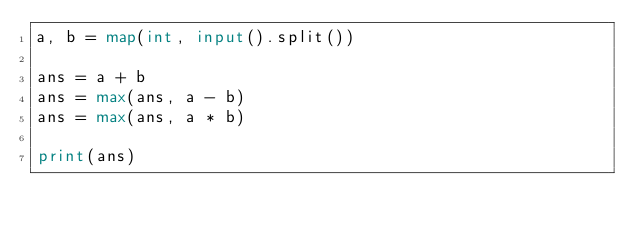<code> <loc_0><loc_0><loc_500><loc_500><_Python_>a, b = map(int, input().split())

ans = a + b
ans = max(ans, a - b)
ans = max(ans, a * b)

print(ans)</code> 